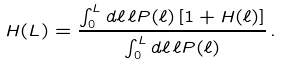<formula> <loc_0><loc_0><loc_500><loc_500>H ( L ) = \frac { \int _ { 0 } ^ { L } d \ell \, \ell P ( \ell ) \left [ 1 + H ( \ell ) \right ] } { \int _ { 0 } ^ { L } d \ell \, \ell P ( \ell ) } \, .</formula> 